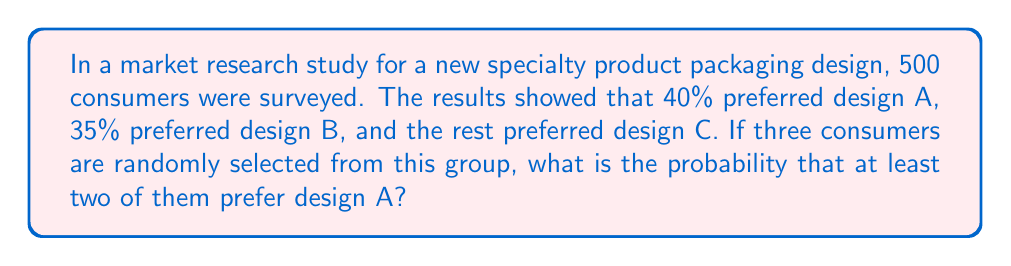Could you help me with this problem? Let's approach this step-by-step:

1) First, we need to calculate the probability of preferring each design:
   P(A) = 40% = 0.4
   P(B) = 35% = 0.35
   P(C) = 100% - 40% - 35% = 25% = 0.25

2) Now, we need to consider the probability of at least two out of three consumers preferring design A. This can happen in two ways:
   - All three prefer A
   - Exactly two prefer A

3) Let's calculate the probability of all three preferring A:
   P(AAA) = $0.4 \times 0.4 \times 0.4 = 0.4^3 = 0.064$

4) Now, let's calculate the probability of exactly two preferring A:
   There are three ways this can happen: AAN, ANA, NAA (where N is not A)
   P(AAN) = $0.4 \times 0.4 \times 0.6 = 0.096$
   This is the same for ANA and NAA

5) So the total probability of exactly two preferring A is:
   P(exactly two A) = $3 \times 0.096 = 0.288$

6) The probability of at least two preferring A is the sum of the probabilities of all three preferring A and exactly two preferring A:
   P(at least two A) = P(AAA) + P(exactly two A)
                     = $0.064 + 0.288 = 0.352$

Therefore, the probability that at least two out of three randomly selected consumers prefer design A is 0.352 or 35.2%.
Answer: 0.352 